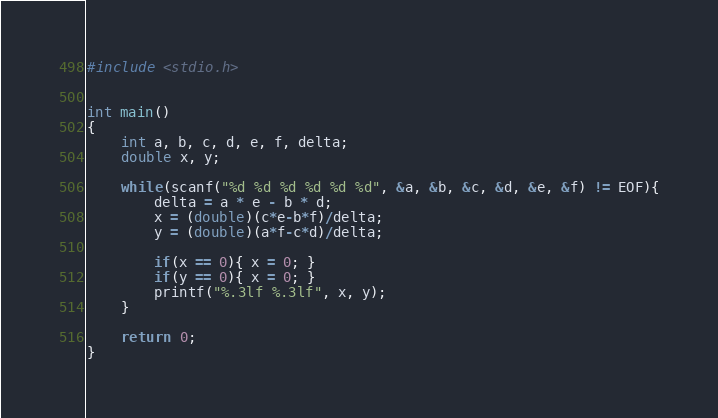Convert code to text. <code><loc_0><loc_0><loc_500><loc_500><_C_>#include <stdio.h>


int main()
{
	int a, b, c, d, e, f, delta;
	double x, y;

	while(scanf("%d %d %d %d %d %d", &a, &b, &c, &d, &e, &f) != EOF){
		delta = a * e - b * d;
		x = (double)(c*e-b*f)/delta;
		y = (double)(a*f-c*d)/delta;

		if(x == 0){ x = 0; }
		if(y == 0){ x = 0; }
		printf("%.3lf %.3lf", x, y);
	}
	
    return 0;
}</code> 